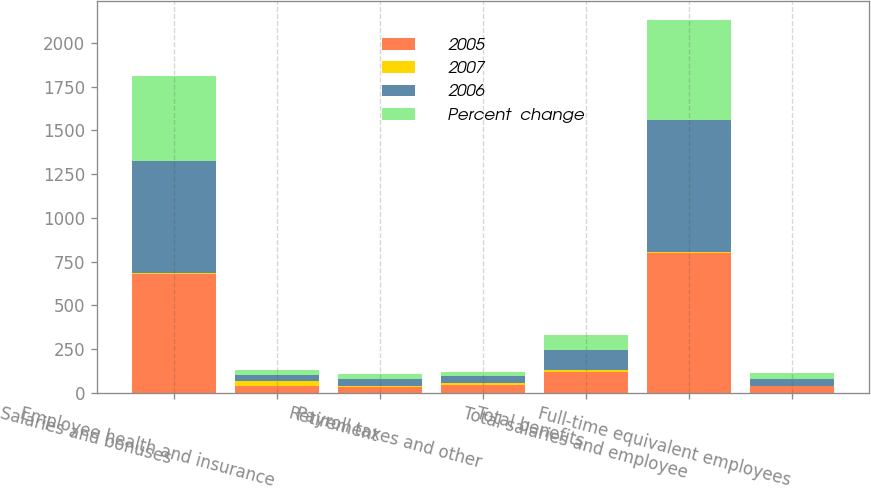Convert chart to OTSL. <chart><loc_0><loc_0><loc_500><loc_500><stacked_bar_chart><ecel><fcel>Salaries and bonuses<fcel>Employee health and insurance<fcel>Retirement<fcel>Payroll taxes and other<fcel>Total benefits<fcel>Total salaries and employee<fcel>Full-time equivalent employees<nl><fcel>2005<fcel>678.1<fcel>42.1<fcel>36.3<fcel>43.4<fcel>121.8<fcel>799.9<fcel>37.8<nl><fcel>2007<fcel>5.8<fcel>24.2<fcel>4<fcel>11.6<fcel>10.1<fcel>6.4<fcel>3<nl><fcel>2006<fcel>641.1<fcel>33.9<fcel>37.8<fcel>38.9<fcel>110.6<fcel>751.7<fcel>37.8<nl><fcel>Percent  change<fcel>486.7<fcel>30.9<fcel>28<fcel>28.3<fcel>87.2<fcel>573.9<fcel>37.8<nl></chart> 